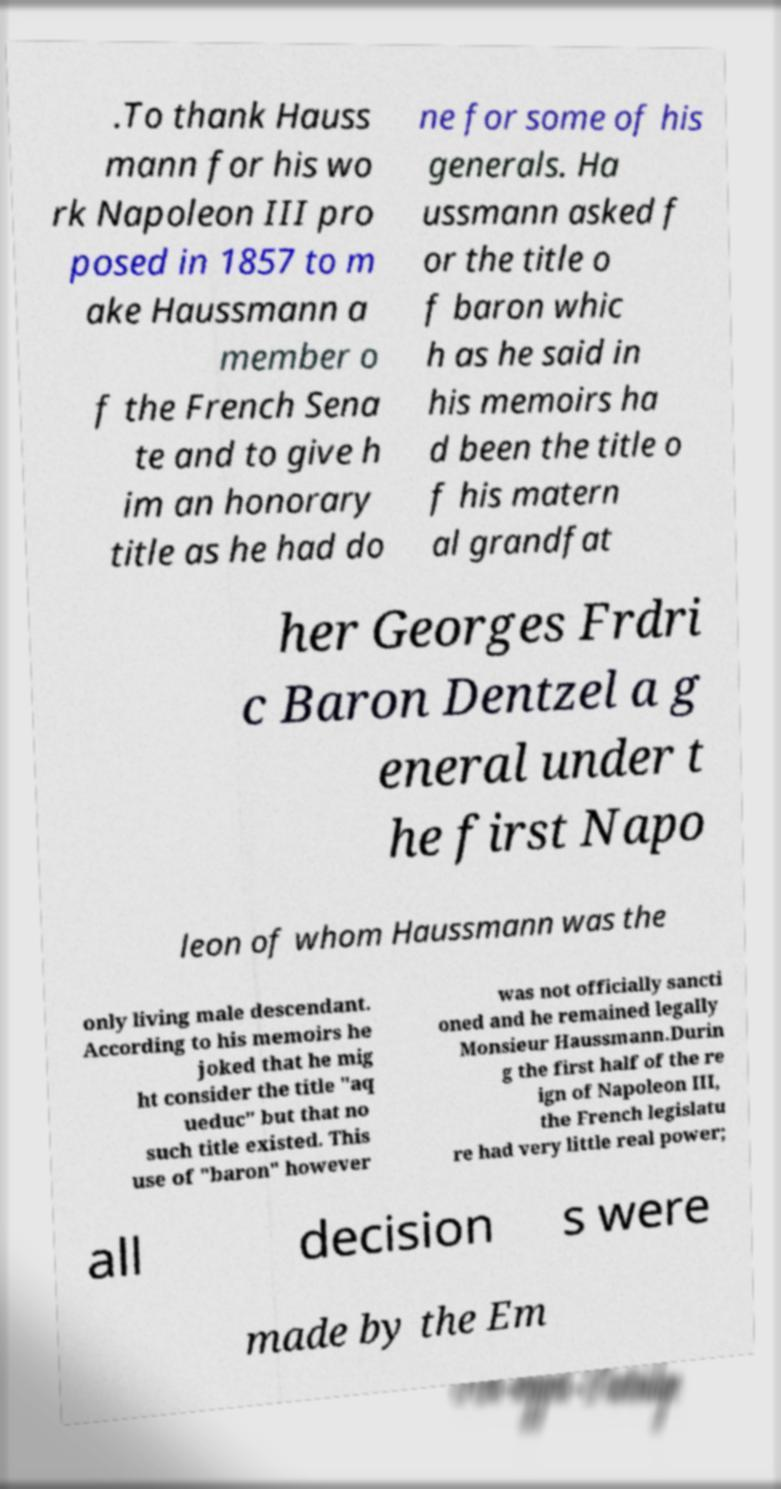I need the written content from this picture converted into text. Can you do that? .To thank Hauss mann for his wo rk Napoleon III pro posed in 1857 to m ake Haussmann a member o f the French Sena te and to give h im an honorary title as he had do ne for some of his generals. Ha ussmann asked f or the title o f baron whic h as he said in his memoirs ha d been the title o f his matern al grandfat her Georges Frdri c Baron Dentzel a g eneral under t he first Napo leon of whom Haussmann was the only living male descendant. According to his memoirs he joked that he mig ht consider the title "aq ueduc" but that no such title existed. This use of "baron" however was not officially sancti oned and he remained legally Monsieur Haussmann.Durin g the first half of the re ign of Napoleon III, the French legislatu re had very little real power; all decision s were made by the Em 